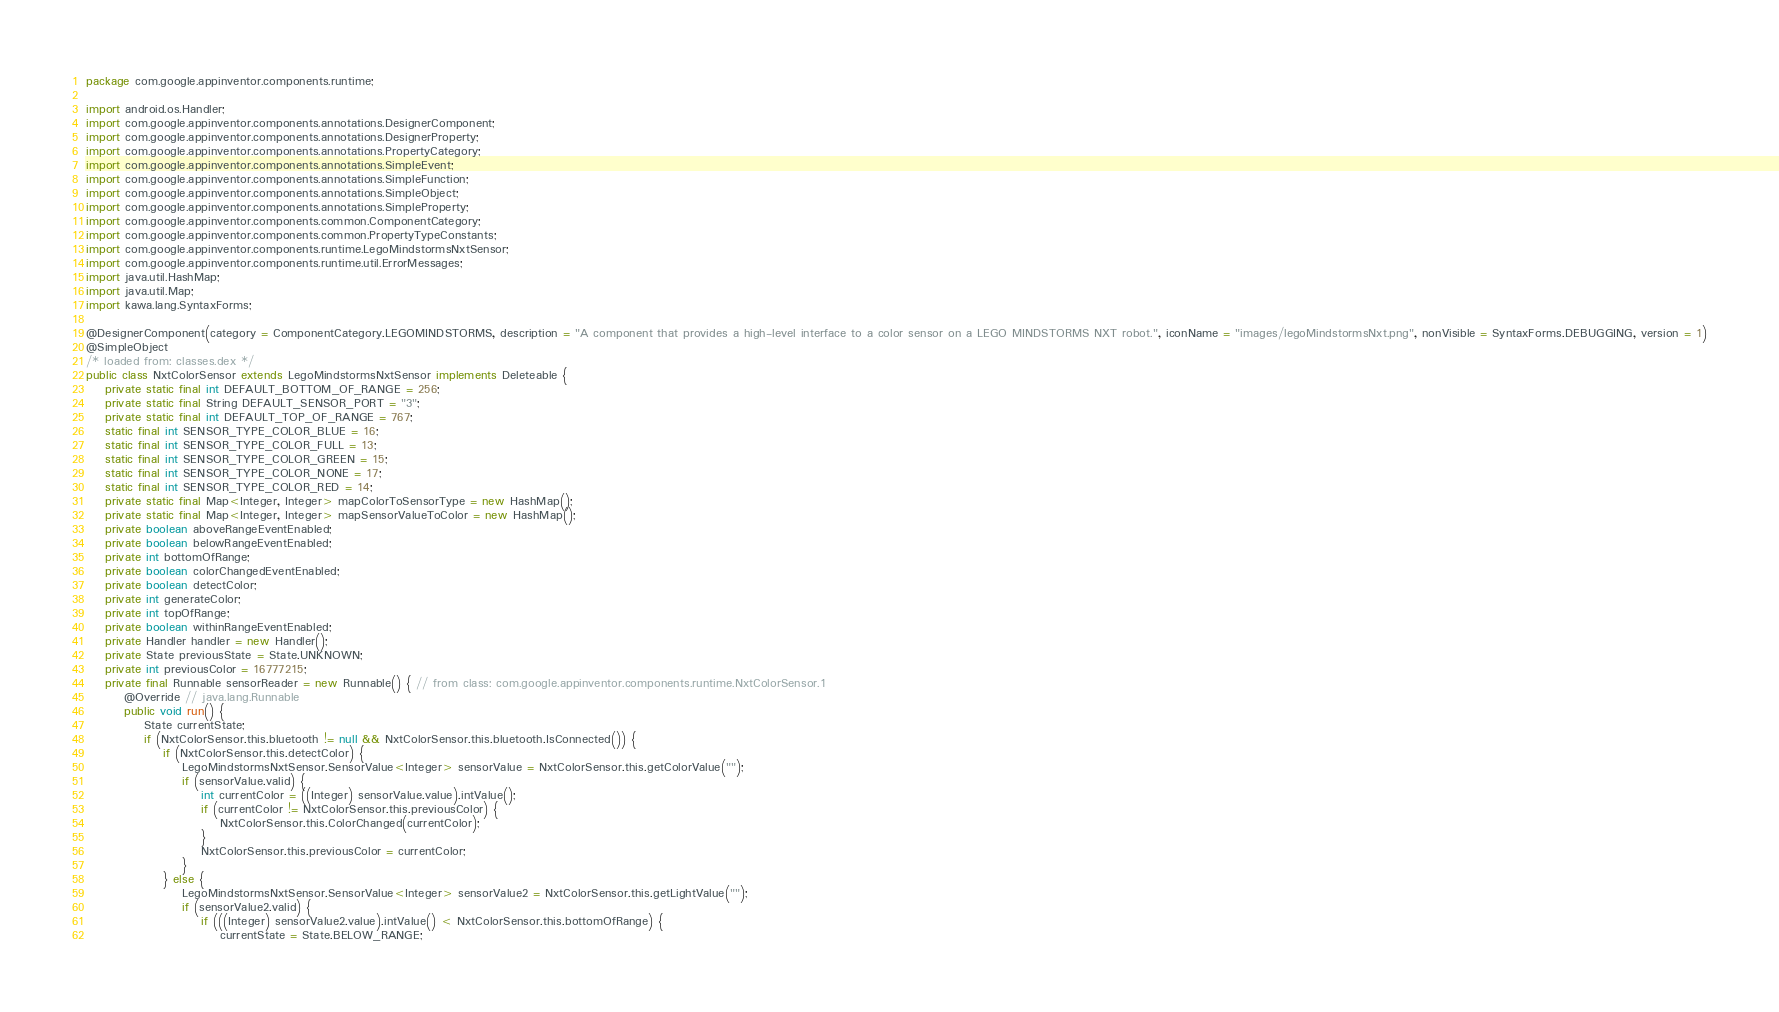Convert code to text. <code><loc_0><loc_0><loc_500><loc_500><_Java_>package com.google.appinventor.components.runtime;

import android.os.Handler;
import com.google.appinventor.components.annotations.DesignerComponent;
import com.google.appinventor.components.annotations.DesignerProperty;
import com.google.appinventor.components.annotations.PropertyCategory;
import com.google.appinventor.components.annotations.SimpleEvent;
import com.google.appinventor.components.annotations.SimpleFunction;
import com.google.appinventor.components.annotations.SimpleObject;
import com.google.appinventor.components.annotations.SimpleProperty;
import com.google.appinventor.components.common.ComponentCategory;
import com.google.appinventor.components.common.PropertyTypeConstants;
import com.google.appinventor.components.runtime.LegoMindstormsNxtSensor;
import com.google.appinventor.components.runtime.util.ErrorMessages;
import java.util.HashMap;
import java.util.Map;
import kawa.lang.SyntaxForms;

@DesignerComponent(category = ComponentCategory.LEGOMINDSTORMS, description = "A component that provides a high-level interface to a color sensor on a LEGO MINDSTORMS NXT robot.", iconName = "images/legoMindstormsNxt.png", nonVisible = SyntaxForms.DEBUGGING, version = 1)
@SimpleObject
/* loaded from: classes.dex */
public class NxtColorSensor extends LegoMindstormsNxtSensor implements Deleteable {
    private static final int DEFAULT_BOTTOM_OF_RANGE = 256;
    private static final String DEFAULT_SENSOR_PORT = "3";
    private static final int DEFAULT_TOP_OF_RANGE = 767;
    static final int SENSOR_TYPE_COLOR_BLUE = 16;
    static final int SENSOR_TYPE_COLOR_FULL = 13;
    static final int SENSOR_TYPE_COLOR_GREEN = 15;
    static final int SENSOR_TYPE_COLOR_NONE = 17;
    static final int SENSOR_TYPE_COLOR_RED = 14;
    private static final Map<Integer, Integer> mapColorToSensorType = new HashMap();
    private static final Map<Integer, Integer> mapSensorValueToColor = new HashMap();
    private boolean aboveRangeEventEnabled;
    private boolean belowRangeEventEnabled;
    private int bottomOfRange;
    private boolean colorChangedEventEnabled;
    private boolean detectColor;
    private int generateColor;
    private int topOfRange;
    private boolean withinRangeEventEnabled;
    private Handler handler = new Handler();
    private State previousState = State.UNKNOWN;
    private int previousColor = 16777215;
    private final Runnable sensorReader = new Runnable() { // from class: com.google.appinventor.components.runtime.NxtColorSensor.1
        @Override // java.lang.Runnable
        public void run() {
            State currentState;
            if (NxtColorSensor.this.bluetooth != null && NxtColorSensor.this.bluetooth.IsConnected()) {
                if (NxtColorSensor.this.detectColor) {
                    LegoMindstormsNxtSensor.SensorValue<Integer> sensorValue = NxtColorSensor.this.getColorValue("");
                    if (sensorValue.valid) {
                        int currentColor = ((Integer) sensorValue.value).intValue();
                        if (currentColor != NxtColorSensor.this.previousColor) {
                            NxtColorSensor.this.ColorChanged(currentColor);
                        }
                        NxtColorSensor.this.previousColor = currentColor;
                    }
                } else {
                    LegoMindstormsNxtSensor.SensorValue<Integer> sensorValue2 = NxtColorSensor.this.getLightValue("");
                    if (sensorValue2.valid) {
                        if (((Integer) sensorValue2.value).intValue() < NxtColorSensor.this.bottomOfRange) {
                            currentState = State.BELOW_RANGE;</code> 